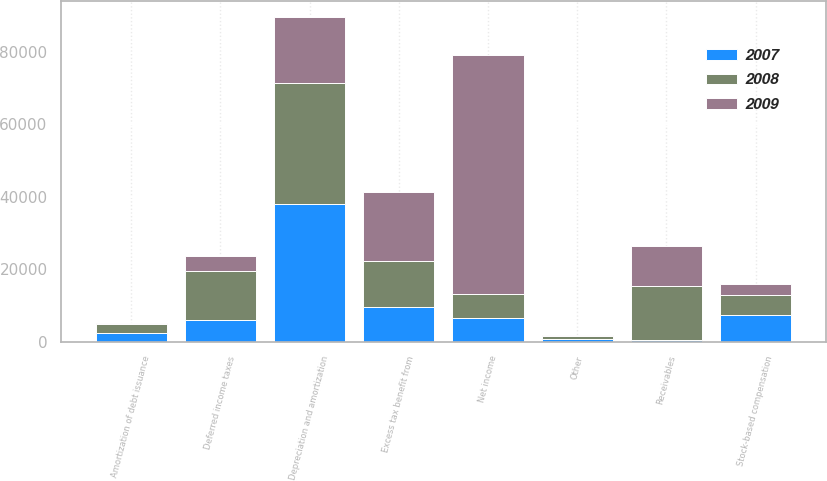<chart> <loc_0><loc_0><loc_500><loc_500><stacked_bar_chart><ecel><fcel>Net income<fcel>Depreciation and amortization<fcel>Stock-based compensation<fcel>Deferred income taxes<fcel>Excess tax benefit from<fcel>Amortization of debt issuance<fcel>Other<fcel>Receivables<nl><fcel>2007<fcel>6582.5<fcel>38062<fcel>7283<fcel>5882<fcel>9628<fcel>2457<fcel>678<fcel>384<nl><fcel>2008<fcel>6582.5<fcel>33421<fcel>5498<fcel>13535<fcel>12547<fcel>2409<fcel>943<fcel>15026<nl><fcel>2009<fcel>65901<fcel>18018<fcel>3039<fcel>4304<fcel>19257<fcel>424<fcel>138<fcel>11026<nl></chart> 